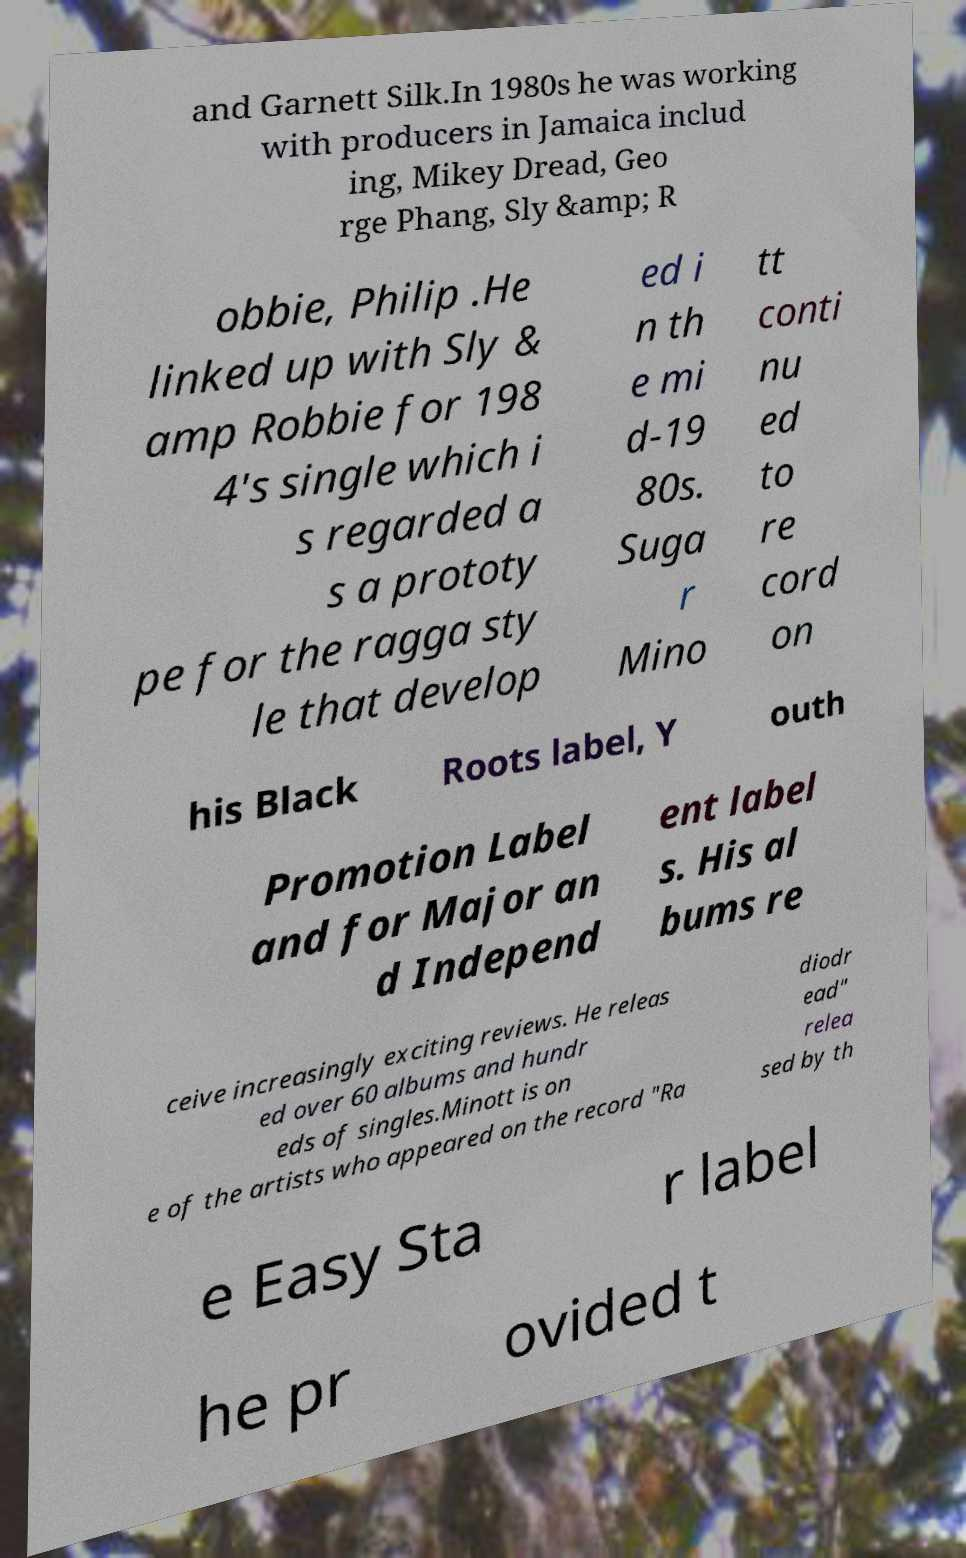Can you read and provide the text displayed in the image?This photo seems to have some interesting text. Can you extract and type it out for me? and Garnett Silk.In 1980s he was working with producers in Jamaica includ ing, Mikey Dread, Geo rge Phang, Sly &amp; R obbie, Philip .He linked up with Sly & amp Robbie for 198 4's single which i s regarded a s a prototy pe for the ragga sty le that develop ed i n th e mi d-19 80s. Suga r Mino tt conti nu ed to re cord on his Black Roots label, Y outh Promotion Label and for Major an d Independ ent label s. His al bums re ceive increasingly exciting reviews. He releas ed over 60 albums and hundr eds of singles.Minott is on e of the artists who appeared on the record "Ra diodr ead" relea sed by th e Easy Sta r label he pr ovided t 